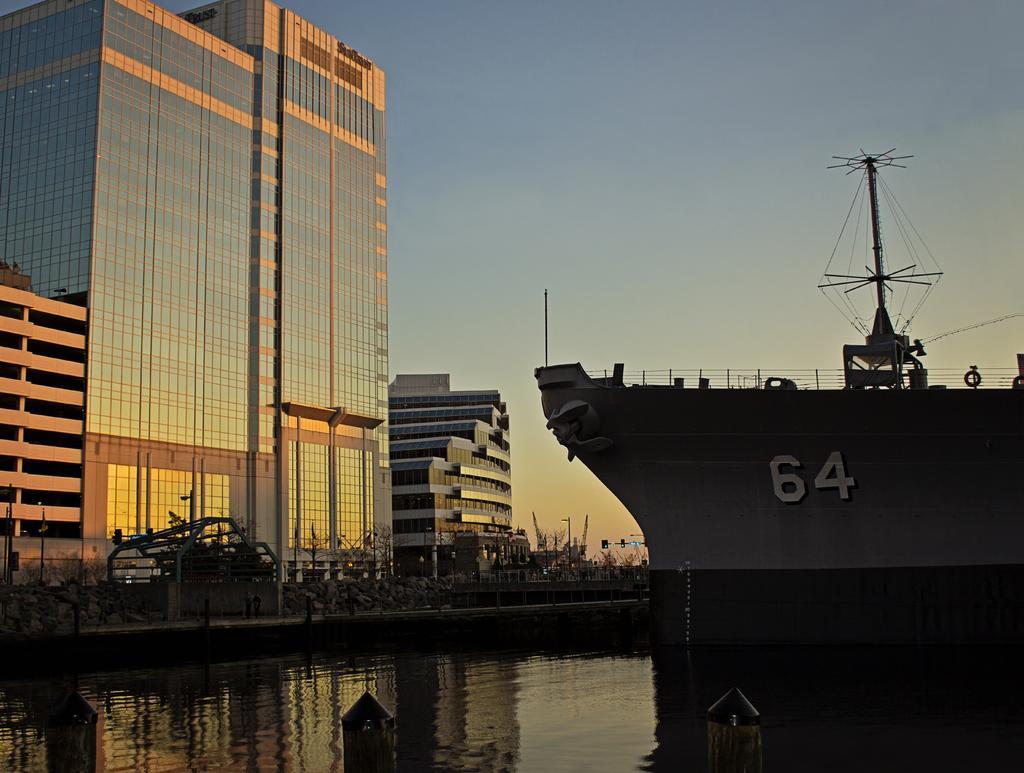Could you give a brief overview of what you see in this image? In this picture we can see a ship on the water and on the ship there is a fence and a pole. On the left side of the ship there are buildings, sky and other items. 